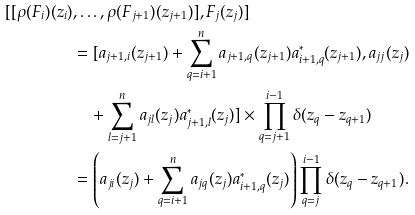<formula> <loc_0><loc_0><loc_500><loc_500>[ [ \rho ( F _ { i } ) ( z _ { i } ) & , \dots , \rho ( F _ { j + 1 } ) ( z _ { j + 1 } ) ] , F _ { j } ( z _ { j } ) ] \\ & = [ a _ { j + 1 , i } ( z _ { j + 1 } ) + \sum _ { q = i + 1 } ^ { n } a _ { j + 1 , q } ( z _ { j + 1 } ) a _ { i + 1 , q } ^ { * } ( z _ { j + 1 } ) , a _ { j j } ( z _ { j } ) \\ & \quad + \sum _ { l = j + 1 } ^ { n } a _ { j l } ( z _ { j } ) a ^ { * } _ { j + 1 , l } ( z _ { j } ) ] \times \prod _ { q = j + 1 } ^ { i - 1 } \delta ( z _ { q } - z _ { q + 1 } ) \\ & = \left ( a _ { j i } ( z _ { j } ) + \sum _ { q = i + 1 } ^ { n } a _ { j q } ( z _ { j } ) a _ { i + 1 , q } ^ { * } ( z _ { j } ) \right ) \prod _ { q = j } ^ { i - 1 } \delta ( z _ { q } - z _ { q + 1 } ) .</formula> 